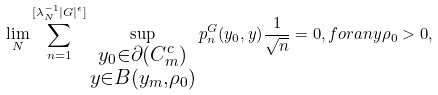<formula> <loc_0><loc_0><loc_500><loc_500>\lim _ { N } \sum _ { n = 1 } ^ { [ \lambda _ { N } ^ { - 1 } | G | ^ { \epsilon } ] } \sup _ { \substack { y _ { 0 } \in \partial ( C _ { m } ^ { c } ) \\ y \in B ( y _ { m } , \rho _ { 0 } ) } } p ^ { G } _ { n } ( y _ { 0 } , y ) \frac { 1 } { \sqrt { n } } = 0 , f o r a n y \rho _ { 0 } > 0 ,</formula> 